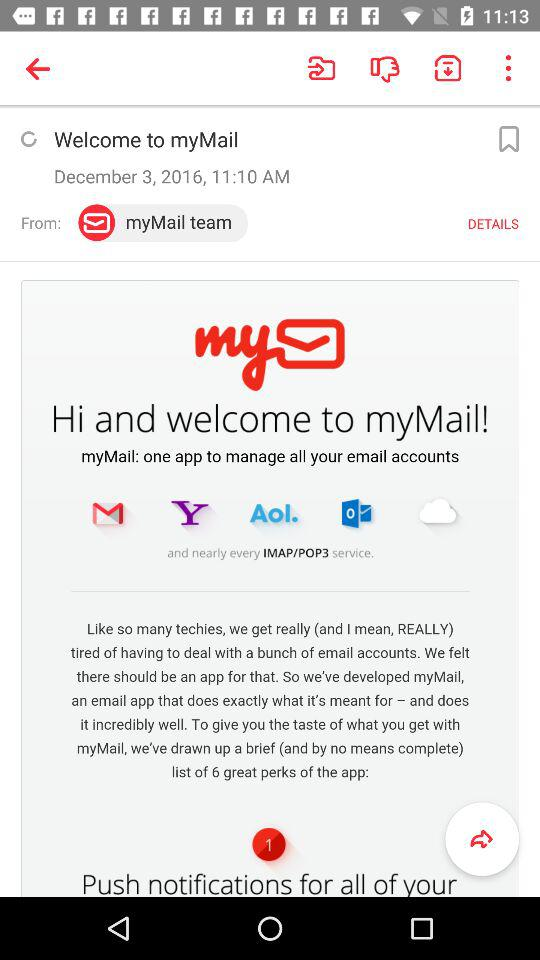What is the mentioned date? The mentioned date is December 3, 2016. 